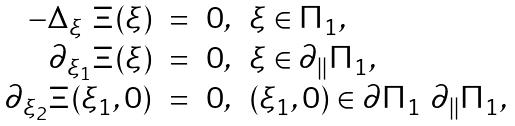<formula> <loc_0><loc_0><loc_500><loc_500>\begin{array} { r c l l } - \Delta _ { \xi } \ \Xi ( \xi ) & = & 0 , & \xi \in \Pi _ { 1 } , \\ \partial _ { \xi _ { 1 } } \Xi ( \xi ) & = & 0 , & \xi \in \partial _ { \| } \Pi _ { 1 } , \\ \partial _ { \xi _ { 2 } } \Xi ( \xi _ { 1 } , 0 ) & = & 0 , & ( \xi _ { 1 } , 0 ) \in \partial \Pi _ { 1 } \ \partial _ { \| } \Pi _ { 1 } , \end{array}</formula> 